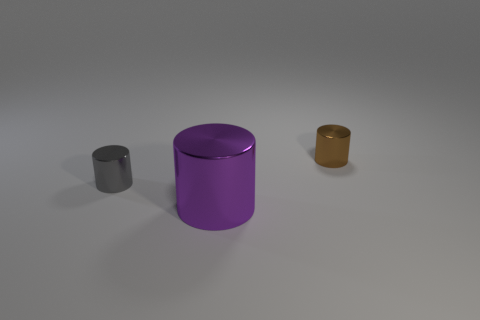What number of purple cylinders have the same material as the brown object?
Make the answer very short. 1. How many things are shiny objects or purple matte blocks?
Offer a very short reply. 3. Is there a small purple metal sphere?
Offer a very short reply. No. Is the number of small gray things that are left of the gray metal cylinder less than the number of brown cylinders?
Provide a short and direct response. Yes. There is a thing that is both on the right side of the tiny gray metal thing and behind the large purple shiny object; what size is it?
Make the answer very short. Small. What size is the purple thing that is the same shape as the brown thing?
Offer a terse response. Large. What number of things are either gray things or things behind the purple shiny thing?
Ensure brevity in your answer.  2. There is a small gray object; what shape is it?
Offer a terse response. Cylinder. There is a thing that is behind the small cylinder that is on the left side of the brown cylinder; what shape is it?
Offer a very short reply. Cylinder. There is another small cylinder that is made of the same material as the gray cylinder; what color is it?
Your response must be concise. Brown. 